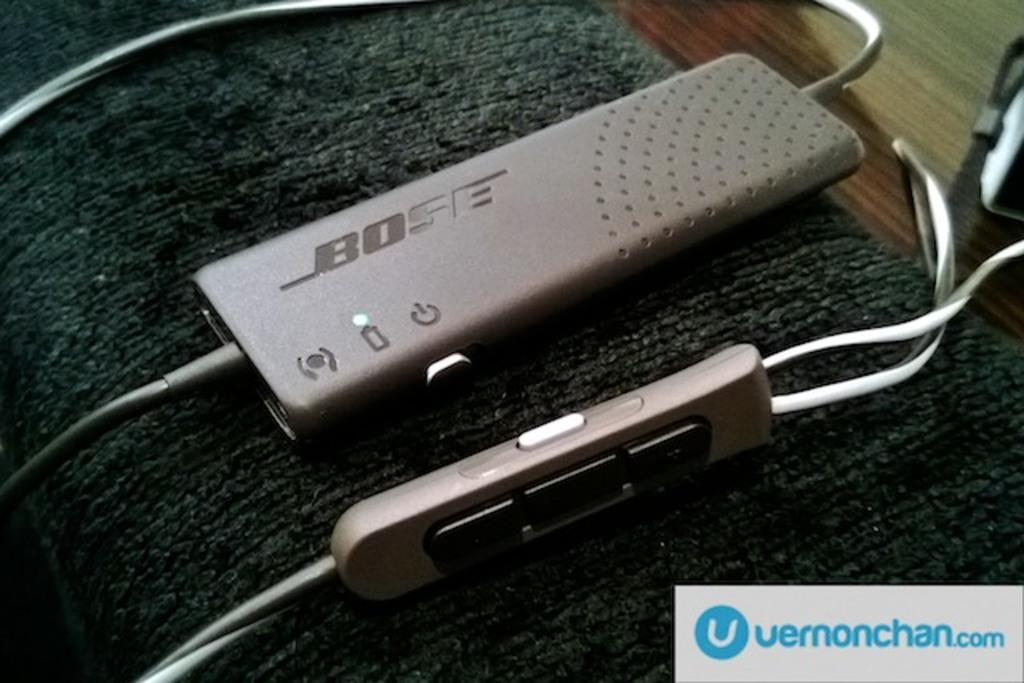<image>
Write a terse but informative summary of the picture. A device from Bose is placed on the arm of a couch. 